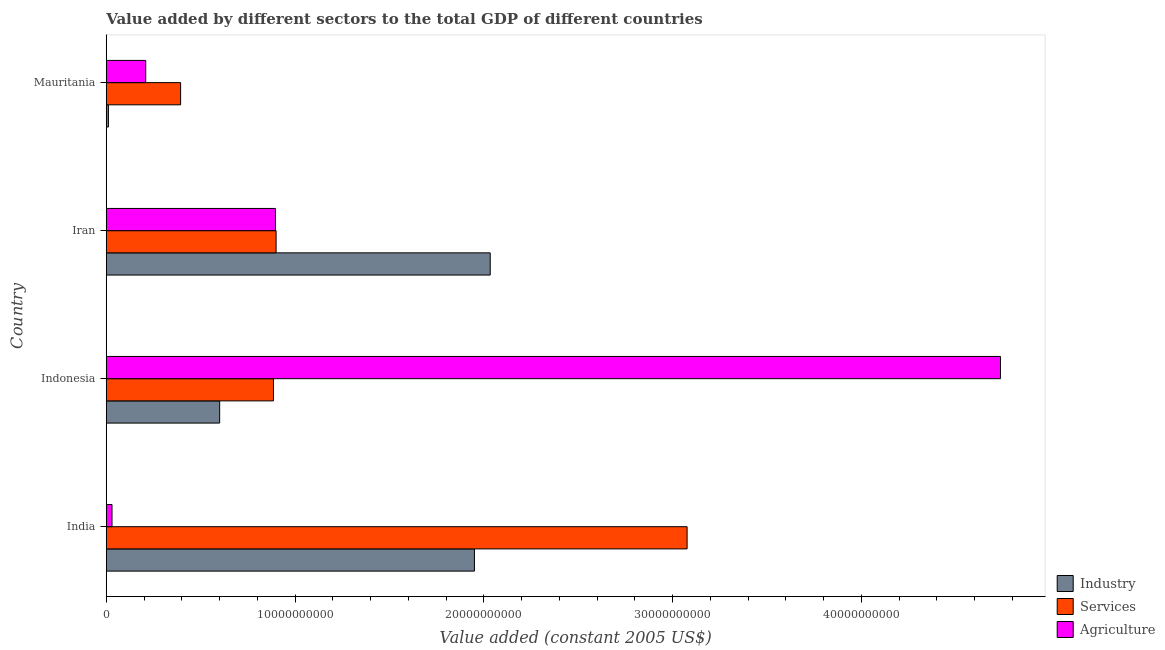How many groups of bars are there?
Keep it short and to the point. 4. How many bars are there on the 1st tick from the top?
Provide a short and direct response. 3. How many bars are there on the 4th tick from the bottom?
Your answer should be very brief. 3. What is the label of the 1st group of bars from the top?
Provide a succinct answer. Mauritania. In how many cases, is the number of bars for a given country not equal to the number of legend labels?
Offer a terse response. 0. What is the value added by industrial sector in Mauritania?
Your answer should be compact. 1.15e+08. Across all countries, what is the maximum value added by services?
Your response must be concise. 3.08e+1. Across all countries, what is the minimum value added by agricultural sector?
Offer a terse response. 3.05e+08. In which country was the value added by industrial sector maximum?
Give a very brief answer. Iran. In which country was the value added by services minimum?
Give a very brief answer. Mauritania. What is the total value added by services in the graph?
Provide a succinct answer. 5.26e+1. What is the difference between the value added by services in Indonesia and that in Mauritania?
Ensure brevity in your answer.  4.92e+09. What is the difference between the value added by industrial sector in Mauritania and the value added by services in India?
Provide a succinct answer. -3.07e+1. What is the average value added by services per country?
Keep it short and to the point. 1.31e+1. What is the difference between the value added by agricultural sector and value added by industrial sector in Indonesia?
Your response must be concise. 4.14e+1. What is the ratio of the value added by industrial sector in India to that in Iran?
Your response must be concise. 0.96. What is the difference between the highest and the second highest value added by industrial sector?
Your answer should be compact. 8.36e+08. What is the difference between the highest and the lowest value added by industrial sector?
Keep it short and to the point. 2.02e+1. In how many countries, is the value added by services greater than the average value added by services taken over all countries?
Ensure brevity in your answer.  1. Is the sum of the value added by industrial sector in Indonesia and Mauritania greater than the maximum value added by agricultural sector across all countries?
Your answer should be very brief. No. What does the 3rd bar from the top in Iran represents?
Offer a very short reply. Industry. What does the 3rd bar from the bottom in Mauritania represents?
Your response must be concise. Agriculture. How many bars are there?
Offer a very short reply. 12. Are the values on the major ticks of X-axis written in scientific E-notation?
Make the answer very short. No. Does the graph contain any zero values?
Give a very brief answer. No. Where does the legend appear in the graph?
Offer a terse response. Bottom right. How many legend labels are there?
Your response must be concise. 3. What is the title of the graph?
Provide a short and direct response. Value added by different sectors to the total GDP of different countries. What is the label or title of the X-axis?
Ensure brevity in your answer.  Value added (constant 2005 US$). What is the Value added (constant 2005 US$) in Industry in India?
Provide a short and direct response. 1.95e+1. What is the Value added (constant 2005 US$) of Services in India?
Your response must be concise. 3.08e+1. What is the Value added (constant 2005 US$) of Agriculture in India?
Your answer should be compact. 3.05e+08. What is the Value added (constant 2005 US$) of Industry in Indonesia?
Your response must be concise. 6.01e+09. What is the Value added (constant 2005 US$) in Services in Indonesia?
Provide a succinct answer. 8.86e+09. What is the Value added (constant 2005 US$) of Agriculture in Indonesia?
Ensure brevity in your answer.  4.74e+1. What is the Value added (constant 2005 US$) in Industry in Iran?
Your answer should be very brief. 2.03e+1. What is the Value added (constant 2005 US$) of Services in Iran?
Provide a succinct answer. 9.00e+09. What is the Value added (constant 2005 US$) of Agriculture in Iran?
Keep it short and to the point. 8.96e+09. What is the Value added (constant 2005 US$) of Industry in Mauritania?
Your answer should be compact. 1.15e+08. What is the Value added (constant 2005 US$) of Services in Mauritania?
Your answer should be compact. 3.94e+09. What is the Value added (constant 2005 US$) of Agriculture in Mauritania?
Make the answer very short. 2.09e+09. Across all countries, what is the maximum Value added (constant 2005 US$) of Industry?
Offer a very short reply. 2.03e+1. Across all countries, what is the maximum Value added (constant 2005 US$) in Services?
Offer a very short reply. 3.08e+1. Across all countries, what is the maximum Value added (constant 2005 US$) of Agriculture?
Provide a succinct answer. 4.74e+1. Across all countries, what is the minimum Value added (constant 2005 US$) in Industry?
Offer a very short reply. 1.15e+08. Across all countries, what is the minimum Value added (constant 2005 US$) of Services?
Make the answer very short. 3.94e+09. Across all countries, what is the minimum Value added (constant 2005 US$) of Agriculture?
Give a very brief answer. 3.05e+08. What is the total Value added (constant 2005 US$) of Industry in the graph?
Keep it short and to the point. 4.60e+1. What is the total Value added (constant 2005 US$) in Services in the graph?
Your answer should be very brief. 5.26e+1. What is the total Value added (constant 2005 US$) in Agriculture in the graph?
Your answer should be very brief. 5.87e+1. What is the difference between the Value added (constant 2005 US$) of Industry in India and that in Indonesia?
Provide a succinct answer. 1.35e+1. What is the difference between the Value added (constant 2005 US$) of Services in India and that in Indonesia?
Provide a short and direct response. 2.19e+1. What is the difference between the Value added (constant 2005 US$) in Agriculture in India and that in Indonesia?
Provide a short and direct response. -4.71e+1. What is the difference between the Value added (constant 2005 US$) of Industry in India and that in Iran?
Your answer should be very brief. -8.36e+08. What is the difference between the Value added (constant 2005 US$) in Services in India and that in Iran?
Offer a terse response. 2.18e+1. What is the difference between the Value added (constant 2005 US$) in Agriculture in India and that in Iran?
Your answer should be compact. -8.66e+09. What is the difference between the Value added (constant 2005 US$) of Industry in India and that in Mauritania?
Keep it short and to the point. 1.94e+1. What is the difference between the Value added (constant 2005 US$) of Services in India and that in Mauritania?
Provide a short and direct response. 2.68e+1. What is the difference between the Value added (constant 2005 US$) in Agriculture in India and that in Mauritania?
Keep it short and to the point. -1.79e+09. What is the difference between the Value added (constant 2005 US$) in Industry in Indonesia and that in Iran?
Offer a terse response. -1.43e+1. What is the difference between the Value added (constant 2005 US$) of Services in Indonesia and that in Iran?
Offer a very short reply. -1.39e+08. What is the difference between the Value added (constant 2005 US$) in Agriculture in Indonesia and that in Iran?
Ensure brevity in your answer.  3.84e+1. What is the difference between the Value added (constant 2005 US$) in Industry in Indonesia and that in Mauritania?
Offer a terse response. 5.89e+09. What is the difference between the Value added (constant 2005 US$) of Services in Indonesia and that in Mauritania?
Provide a short and direct response. 4.92e+09. What is the difference between the Value added (constant 2005 US$) in Agriculture in Indonesia and that in Mauritania?
Make the answer very short. 4.53e+1. What is the difference between the Value added (constant 2005 US$) of Industry in Iran and that in Mauritania?
Your response must be concise. 2.02e+1. What is the difference between the Value added (constant 2005 US$) in Services in Iran and that in Mauritania?
Your answer should be compact. 5.06e+09. What is the difference between the Value added (constant 2005 US$) in Agriculture in Iran and that in Mauritania?
Provide a short and direct response. 6.87e+09. What is the difference between the Value added (constant 2005 US$) in Industry in India and the Value added (constant 2005 US$) in Services in Indonesia?
Make the answer very short. 1.06e+1. What is the difference between the Value added (constant 2005 US$) of Industry in India and the Value added (constant 2005 US$) of Agriculture in Indonesia?
Your answer should be very brief. -2.79e+1. What is the difference between the Value added (constant 2005 US$) in Services in India and the Value added (constant 2005 US$) in Agriculture in Indonesia?
Provide a short and direct response. -1.66e+1. What is the difference between the Value added (constant 2005 US$) in Industry in India and the Value added (constant 2005 US$) in Services in Iran?
Keep it short and to the point. 1.05e+1. What is the difference between the Value added (constant 2005 US$) of Industry in India and the Value added (constant 2005 US$) of Agriculture in Iran?
Provide a short and direct response. 1.05e+1. What is the difference between the Value added (constant 2005 US$) in Services in India and the Value added (constant 2005 US$) in Agriculture in Iran?
Offer a terse response. 2.18e+1. What is the difference between the Value added (constant 2005 US$) of Industry in India and the Value added (constant 2005 US$) of Services in Mauritania?
Offer a terse response. 1.56e+1. What is the difference between the Value added (constant 2005 US$) of Industry in India and the Value added (constant 2005 US$) of Agriculture in Mauritania?
Ensure brevity in your answer.  1.74e+1. What is the difference between the Value added (constant 2005 US$) in Services in India and the Value added (constant 2005 US$) in Agriculture in Mauritania?
Your answer should be compact. 2.87e+1. What is the difference between the Value added (constant 2005 US$) of Industry in Indonesia and the Value added (constant 2005 US$) of Services in Iran?
Your response must be concise. -2.99e+09. What is the difference between the Value added (constant 2005 US$) in Industry in Indonesia and the Value added (constant 2005 US$) in Agriculture in Iran?
Provide a short and direct response. -2.96e+09. What is the difference between the Value added (constant 2005 US$) of Services in Indonesia and the Value added (constant 2005 US$) of Agriculture in Iran?
Offer a very short reply. -1.05e+08. What is the difference between the Value added (constant 2005 US$) in Industry in Indonesia and the Value added (constant 2005 US$) in Services in Mauritania?
Provide a short and direct response. 2.07e+09. What is the difference between the Value added (constant 2005 US$) in Industry in Indonesia and the Value added (constant 2005 US$) in Agriculture in Mauritania?
Give a very brief answer. 3.92e+09. What is the difference between the Value added (constant 2005 US$) of Services in Indonesia and the Value added (constant 2005 US$) of Agriculture in Mauritania?
Provide a succinct answer. 6.77e+09. What is the difference between the Value added (constant 2005 US$) of Industry in Iran and the Value added (constant 2005 US$) of Services in Mauritania?
Your answer should be very brief. 1.64e+1. What is the difference between the Value added (constant 2005 US$) of Industry in Iran and the Value added (constant 2005 US$) of Agriculture in Mauritania?
Make the answer very short. 1.82e+1. What is the difference between the Value added (constant 2005 US$) of Services in Iran and the Value added (constant 2005 US$) of Agriculture in Mauritania?
Provide a succinct answer. 6.91e+09. What is the average Value added (constant 2005 US$) in Industry per country?
Ensure brevity in your answer.  1.15e+1. What is the average Value added (constant 2005 US$) of Services per country?
Ensure brevity in your answer.  1.31e+1. What is the average Value added (constant 2005 US$) of Agriculture per country?
Ensure brevity in your answer.  1.47e+1. What is the difference between the Value added (constant 2005 US$) in Industry and Value added (constant 2005 US$) in Services in India?
Ensure brevity in your answer.  -1.13e+1. What is the difference between the Value added (constant 2005 US$) of Industry and Value added (constant 2005 US$) of Agriculture in India?
Your answer should be compact. 1.92e+1. What is the difference between the Value added (constant 2005 US$) of Services and Value added (constant 2005 US$) of Agriculture in India?
Give a very brief answer. 3.05e+1. What is the difference between the Value added (constant 2005 US$) in Industry and Value added (constant 2005 US$) in Services in Indonesia?
Keep it short and to the point. -2.85e+09. What is the difference between the Value added (constant 2005 US$) in Industry and Value added (constant 2005 US$) in Agriculture in Indonesia?
Give a very brief answer. -4.14e+1. What is the difference between the Value added (constant 2005 US$) of Services and Value added (constant 2005 US$) of Agriculture in Indonesia?
Make the answer very short. -3.85e+1. What is the difference between the Value added (constant 2005 US$) of Industry and Value added (constant 2005 US$) of Services in Iran?
Your response must be concise. 1.13e+1. What is the difference between the Value added (constant 2005 US$) of Industry and Value added (constant 2005 US$) of Agriculture in Iran?
Make the answer very short. 1.14e+1. What is the difference between the Value added (constant 2005 US$) of Services and Value added (constant 2005 US$) of Agriculture in Iran?
Offer a very short reply. 3.41e+07. What is the difference between the Value added (constant 2005 US$) of Industry and Value added (constant 2005 US$) of Services in Mauritania?
Keep it short and to the point. -3.82e+09. What is the difference between the Value added (constant 2005 US$) in Industry and Value added (constant 2005 US$) in Agriculture in Mauritania?
Offer a very short reply. -1.98e+09. What is the difference between the Value added (constant 2005 US$) in Services and Value added (constant 2005 US$) in Agriculture in Mauritania?
Provide a short and direct response. 1.85e+09. What is the ratio of the Value added (constant 2005 US$) of Industry in India to that in Indonesia?
Give a very brief answer. 3.25. What is the ratio of the Value added (constant 2005 US$) of Services in India to that in Indonesia?
Your answer should be compact. 3.47. What is the ratio of the Value added (constant 2005 US$) of Agriculture in India to that in Indonesia?
Offer a terse response. 0.01. What is the ratio of the Value added (constant 2005 US$) of Industry in India to that in Iran?
Ensure brevity in your answer.  0.96. What is the ratio of the Value added (constant 2005 US$) in Services in India to that in Iran?
Make the answer very short. 3.42. What is the ratio of the Value added (constant 2005 US$) of Agriculture in India to that in Iran?
Provide a short and direct response. 0.03. What is the ratio of the Value added (constant 2005 US$) of Industry in India to that in Mauritania?
Offer a terse response. 169.07. What is the ratio of the Value added (constant 2005 US$) in Services in India to that in Mauritania?
Provide a succinct answer. 7.81. What is the ratio of the Value added (constant 2005 US$) in Agriculture in India to that in Mauritania?
Provide a short and direct response. 0.15. What is the ratio of the Value added (constant 2005 US$) in Industry in Indonesia to that in Iran?
Make the answer very short. 0.3. What is the ratio of the Value added (constant 2005 US$) of Services in Indonesia to that in Iran?
Your answer should be very brief. 0.98. What is the ratio of the Value added (constant 2005 US$) of Agriculture in Indonesia to that in Iran?
Your response must be concise. 5.28. What is the ratio of the Value added (constant 2005 US$) in Industry in Indonesia to that in Mauritania?
Your answer should be very brief. 52.07. What is the ratio of the Value added (constant 2005 US$) in Services in Indonesia to that in Mauritania?
Your answer should be very brief. 2.25. What is the ratio of the Value added (constant 2005 US$) in Agriculture in Indonesia to that in Mauritania?
Your response must be concise. 22.65. What is the ratio of the Value added (constant 2005 US$) of Industry in Iran to that in Mauritania?
Keep it short and to the point. 176.32. What is the ratio of the Value added (constant 2005 US$) in Services in Iran to that in Mauritania?
Your answer should be compact. 2.28. What is the ratio of the Value added (constant 2005 US$) of Agriculture in Iran to that in Mauritania?
Provide a succinct answer. 4.29. What is the difference between the highest and the second highest Value added (constant 2005 US$) in Industry?
Provide a succinct answer. 8.36e+08. What is the difference between the highest and the second highest Value added (constant 2005 US$) of Services?
Keep it short and to the point. 2.18e+1. What is the difference between the highest and the second highest Value added (constant 2005 US$) in Agriculture?
Offer a terse response. 3.84e+1. What is the difference between the highest and the lowest Value added (constant 2005 US$) in Industry?
Ensure brevity in your answer.  2.02e+1. What is the difference between the highest and the lowest Value added (constant 2005 US$) in Services?
Your answer should be very brief. 2.68e+1. What is the difference between the highest and the lowest Value added (constant 2005 US$) of Agriculture?
Your answer should be compact. 4.71e+1. 